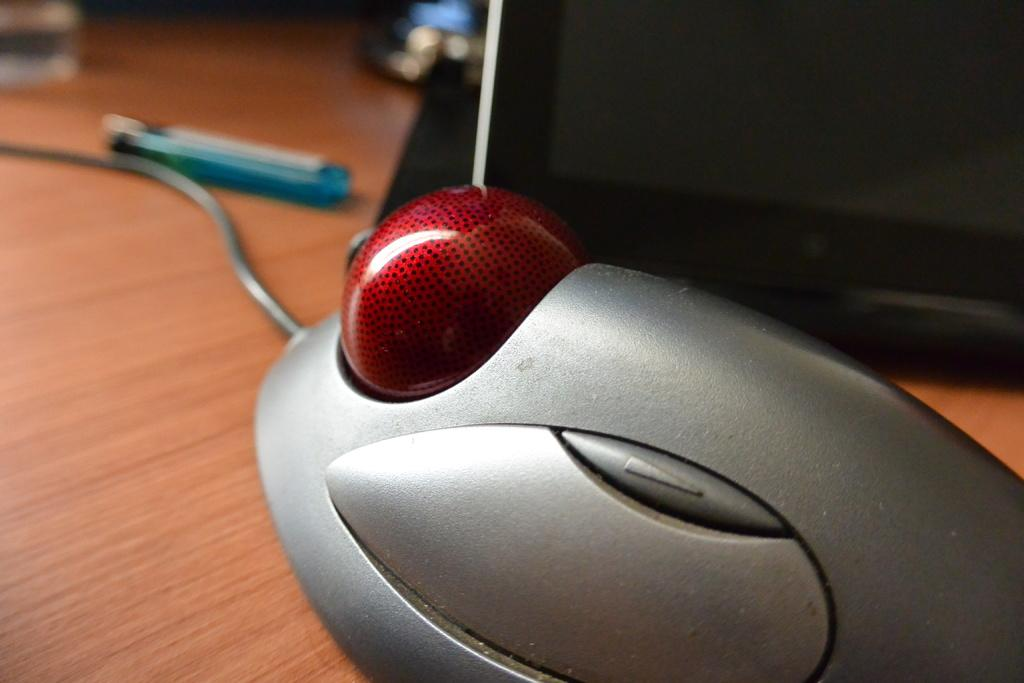What is the main object in the image that is attached to a wire? There is an object attached to a wire in the image, but the specific object is not mentioned in the facts. What can be seen on the wooden surface in the background of the image? There are other objects on a wooden surface in the background of the image, but the specific objects are not mentioned in the facts. Can you tell me how many hens are present in the image? There is no hen present in the image; it only mentions an object attached to a wire and other objects on a wooden surface in the background. Is there a locket hanging from the wire in the image? The specific object attached to the wire is not mentioned in the facts, so it cannot be determined if it is a locket or not. Can you describe the relationship between the objects in the image and the person who took the photo? The facts provided do not mention any people or relationships, so it cannot be determined if there is a brother or any other person involved in the image. 